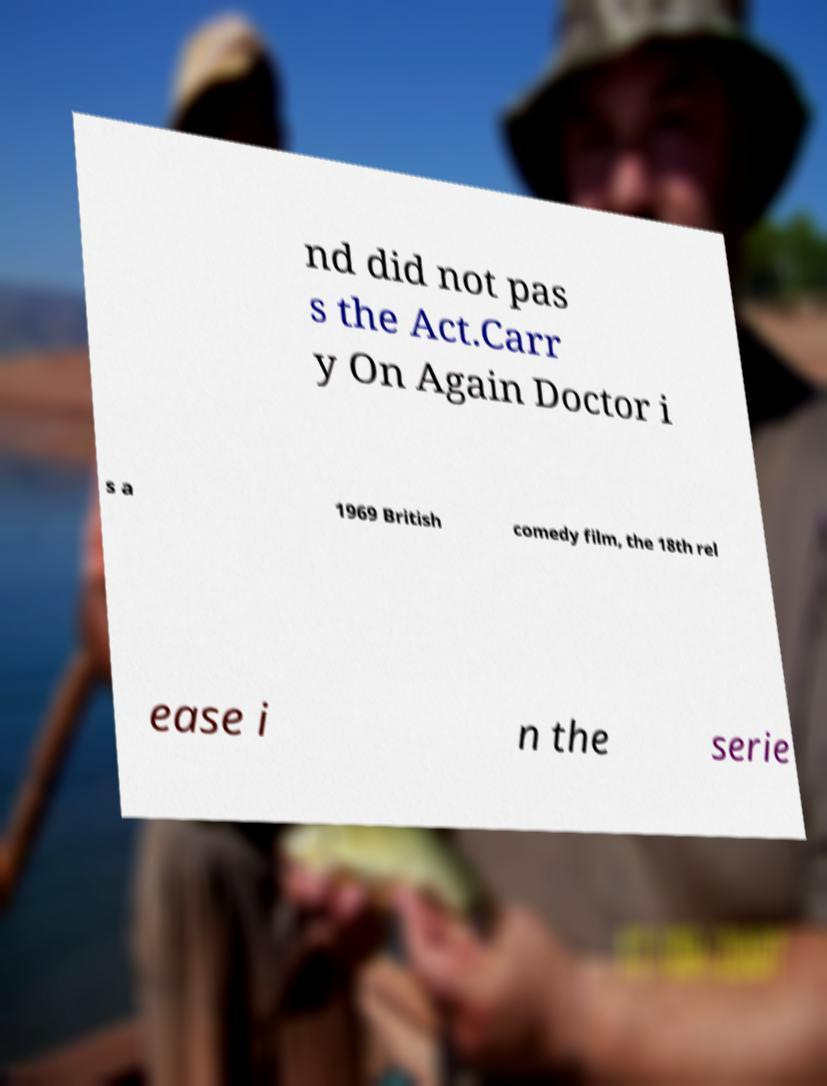Can you read and provide the text displayed in the image?This photo seems to have some interesting text. Can you extract and type it out for me? nd did not pas s the Act.Carr y On Again Doctor i s a 1969 British comedy film, the 18th rel ease i n the serie 